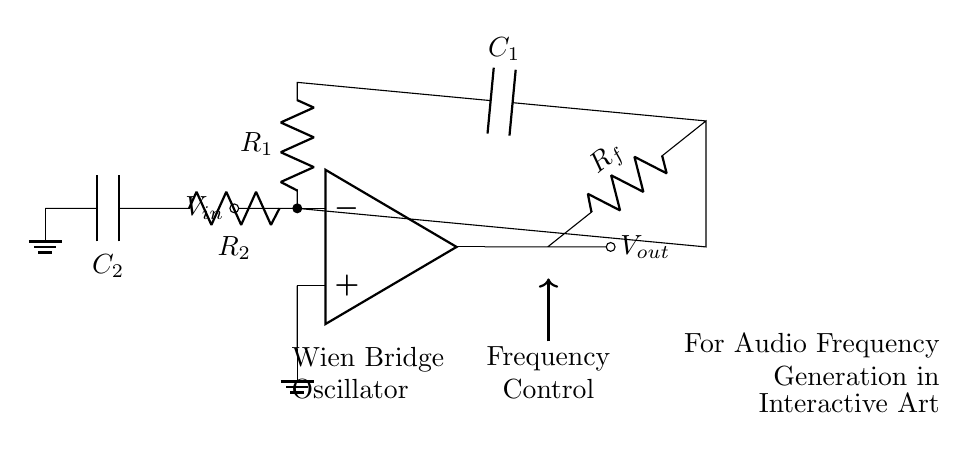What is the type of amplifier used in this circuit? The circuit uses an operational amplifier, as indicated by the op amp symbol in the diagram.
Answer: operational amplifier Which components are responsible for frequency control? The frequency control is provided by the resistors R1 and R2, along with the capacitors C1 and C2, which are part of the Wien bridge configuration.
Answer: R1, R2, C1, C2 How many resistors are present in the circuit? There are three resistors in this circuit: R1, R2, and Rf, as illustrated by the resistor symbols in the diagram.
Answer: 3 What is the configuration of the circuit? The circuit is a Wien bridge oscillator, which is designed for generating audio frequencies and is composed of the specified components working together.
Answer: Wien bridge oscillator What is the primary application of this oscillator? The primary application of the Wien bridge oscillator, as stated in the label, is for audio frequency generation in interactive art installations.
Answer: audio frequency generation in interactive art installations What connections are used to ground the circuit? The circuit is grounded through the ground node connected to C2 and the negative terminal of the op amp, ensuring a common reference point for the circuit.
Answer: op amp negative terminal and C2 